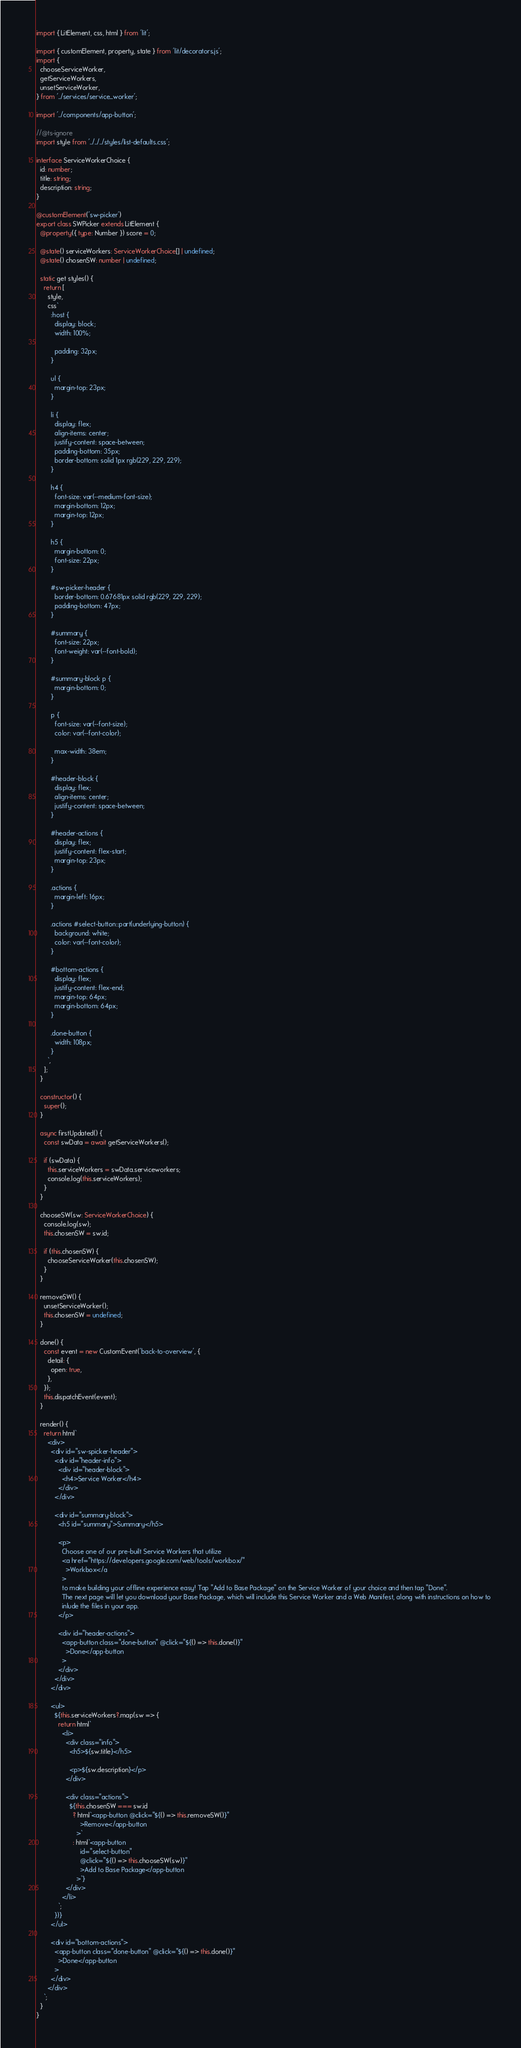Convert code to text. <code><loc_0><loc_0><loc_500><loc_500><_TypeScript_>import { LitElement, css, html } from 'lit';

import { customElement, property, state } from 'lit/decorators.js';
import {
  chooseServiceWorker,
  getServiceWorkers,
  unsetServiceWorker,
} from '../services/service_worker';

import '../components/app-button';

//@ts-ignore
import style from '../../../styles/list-defaults.css';

interface ServiceWorkerChoice {
  id: number;
  title: string;
  description: string;
}

@customElement('sw-picker')
export class SWPicker extends LitElement {
  @property({ type: Number }) score = 0;

  @state() serviceWorkers: ServiceWorkerChoice[] | undefined;
  @state() chosenSW: number | undefined;

  static get styles() {
    return [
      style,
      css`
        :host {
          display: block;
          width: 100%;

          padding: 32px;
        }

        ul {
          margin-top: 23px;
        }

        li {
          display: flex;
          align-items: center;
          justify-content: space-between;
          padding-bottom: 35px;
          border-bottom: solid 1px rgb(229, 229, 229);
        }

        h4 {
          font-size: var(--medium-font-size);
          margin-bottom: 12px;
          margin-top: 12px;
        }

        h5 {
          margin-bottom: 0;
          font-size: 22px;
        }

        #sw-picker-header {
          border-bottom: 0.67681px solid rgb(229, 229, 229);
          padding-bottom: 47px;
        }

        #summary {
          font-size: 22px;
          font-weight: var(--font-bold);
        }

        #summary-block p {
          margin-bottom: 0;
        }

        p {
          font-size: var(--font-size);
          color: var(--font-color);

          max-width: 38em;
        }

        #header-block {
          display: flex;
          align-items: center;
          justify-content: space-between;
        }

        #header-actions {
          display: flex;
          justify-content: flex-start;
          margin-top: 23px;
        }

        .actions {
          margin-left: 16px;
        }

        .actions #select-button::part(underlying-button) {
          background: white;
          color: var(--font-color);
        }

        #bottom-actions {
          display: flex;
          justify-content: flex-end;
          margin-top: 64px;
          margin-bottom: 64px;
        }

        .done-button {
          width: 108px;
        }
      `,
    ];
  }

  constructor() {
    super();
  }

  async firstUpdated() {
    const swData = await getServiceWorkers();

    if (swData) {
      this.serviceWorkers = swData.serviceworkers;
      console.log(this.serviceWorkers);
    }
  }

  chooseSW(sw: ServiceWorkerChoice) {
    console.log(sw);
    this.chosenSW = sw.id;

    if (this.chosenSW) {
      chooseServiceWorker(this.chosenSW);
    }
  }

  removeSW() {
    unsetServiceWorker();
    this.chosenSW = undefined;
  }

  done() {
    const event = new CustomEvent('back-to-overview', {
      detail: {
        open: true,
      },
    });
    this.dispatchEvent(event);
  }

  render() {
    return html`
      <div>
        <div id="sw-spicker-header">
          <div id="header-info">
            <div id="header-block">
              <h4>Service Worker</h4>
            </div>
          </div>

          <div id="summary-block">
            <h5 id="summary">Summary</h5>

            <p>
              Choose one of our pre-built Service Workers that utilize
              <a href="https://developers.google.com/web/tools/workbox/"
                >Workbox</a
              >
              to make building your offline experience easy! Tap "Add to Base Package" on the Service Worker of your choice and then tap "Done".
              The next page will let you download your Base Package, which will include this Service Worker and a Web Manifest, along with instructions on how to 
              inlude the files in your app.
            </p>

            <div id="header-actions">
              <app-button class="done-button" @click="${() => this.done()}"
                >Done</app-button
              >
            </div>
          </div>
        </div>

        <ul>
          ${this.serviceWorkers?.map(sw => {
            return html`
              <li>
                <div class="info">
                  <h5>${sw.title}</h5>

                  <p>${sw.description}</p>
                </div>

                <div class="actions">
                  ${this.chosenSW === sw.id
                    ? html`<app-button @click="${() => this.removeSW()}"
                        >Remove</app-button
                      >`
                    : html`<app-button
                        id="select-button"
                        @click="${() => this.chooseSW(sw)}"
                        >Add to Base Package</app-button
                      >`}
                </div>
              </li>
            `;
          })}
        </ul>

        <div id="bottom-actions">
          <app-button class="done-button" @click="${() => this.done()}"
            >Done</app-button
          >
        </div>
      </div>
    `;
  }
}
</code> 